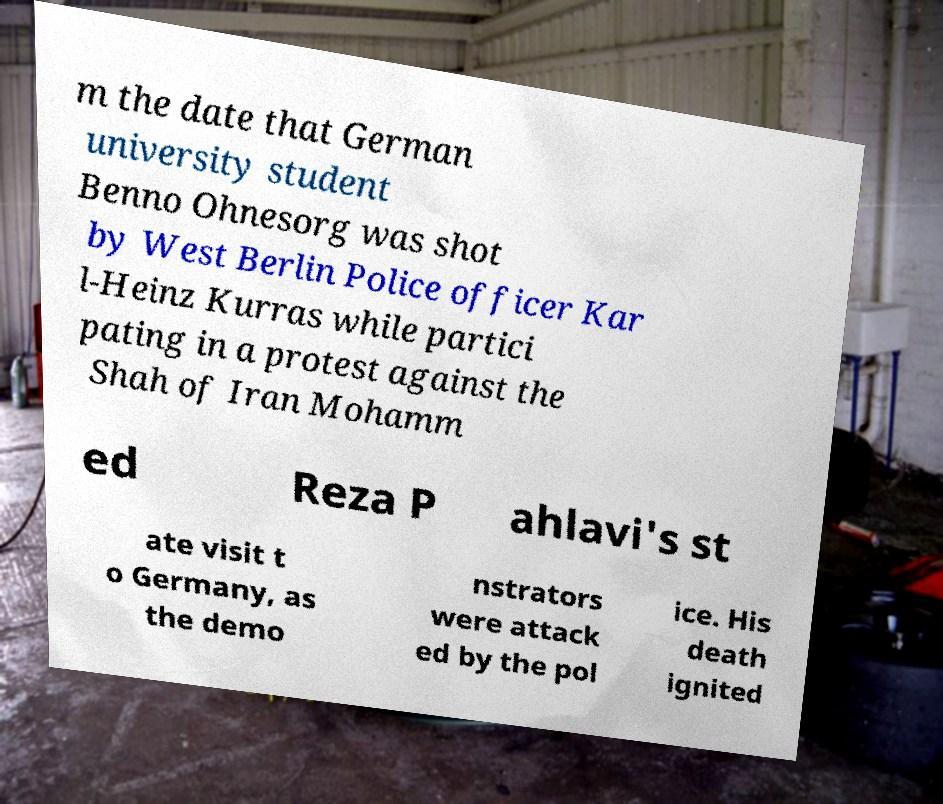For documentation purposes, I need the text within this image transcribed. Could you provide that? m the date that German university student Benno Ohnesorg was shot by West Berlin Police officer Kar l-Heinz Kurras while partici pating in a protest against the Shah of Iran Mohamm ed Reza P ahlavi's st ate visit t o Germany, as the demo nstrators were attack ed by the pol ice. His death ignited 